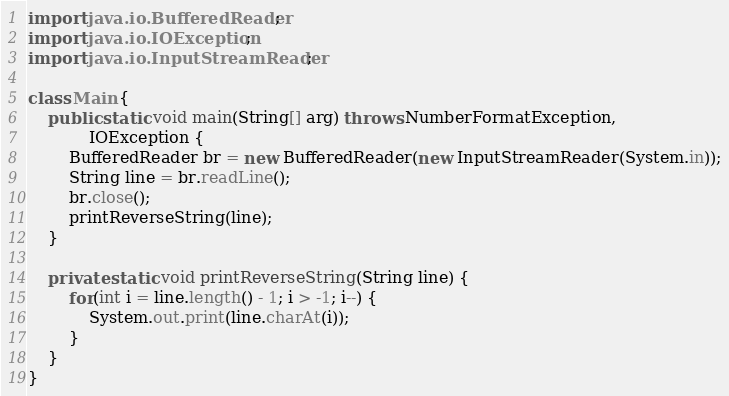<code> <loc_0><loc_0><loc_500><loc_500><_Java_>import java.io.BufferedReader;
import java.io.IOException;
import java.io.InputStreamReader;

class Main {
	public static void main(String[] arg) throws NumberFormatException,
			IOException {
		BufferedReader br = new BufferedReader(new InputStreamReader(System.in));
		String line = br.readLine();
		br.close();
		printReverseString(line);
	}

	private static void printReverseString(String line) {
		for(int i = line.length() - 1; i > -1; i--) {
			System.out.print(line.charAt(i));
		}
	}
}</code> 